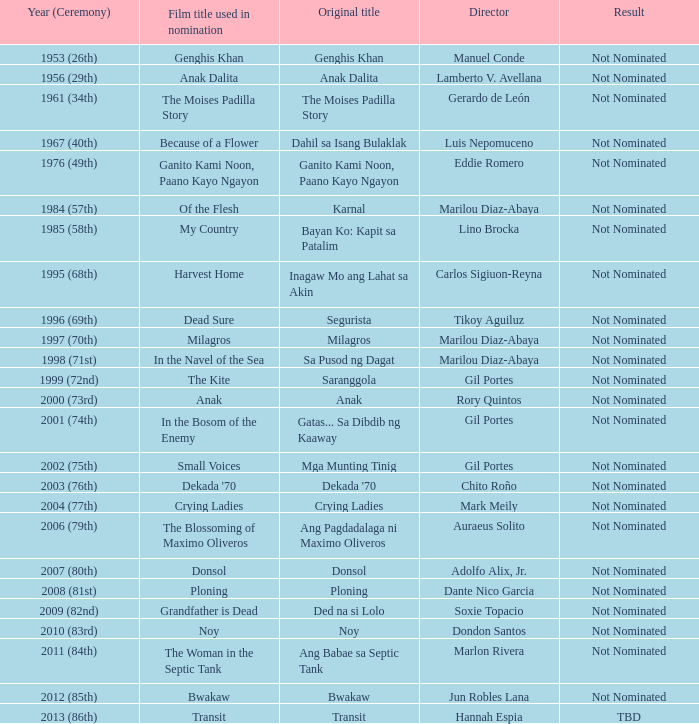In what year was the film in the navel of the sea utilized for nomination, but the result was not being nominated? 1998 (71st). 